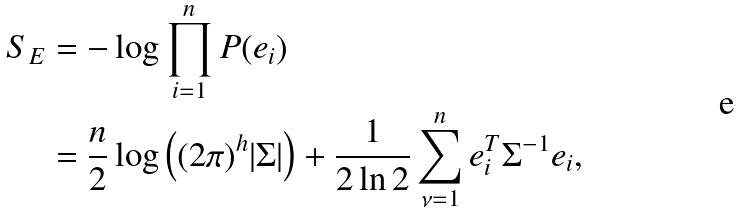Convert formula to latex. <formula><loc_0><loc_0><loc_500><loc_500>S _ { E } & = - \log \prod _ { i = 1 } ^ { n } P ( e _ { i } ) \\ & = \frac { n } { 2 } \log { \left ( ( 2 \pi ) ^ { h } | \Sigma | \right ) } + \frac { 1 } { 2 \ln 2 } \sum _ { \nu = 1 } ^ { n } e _ { i } ^ { T } \Sigma ^ { - 1 } e _ { i } , \\</formula> 